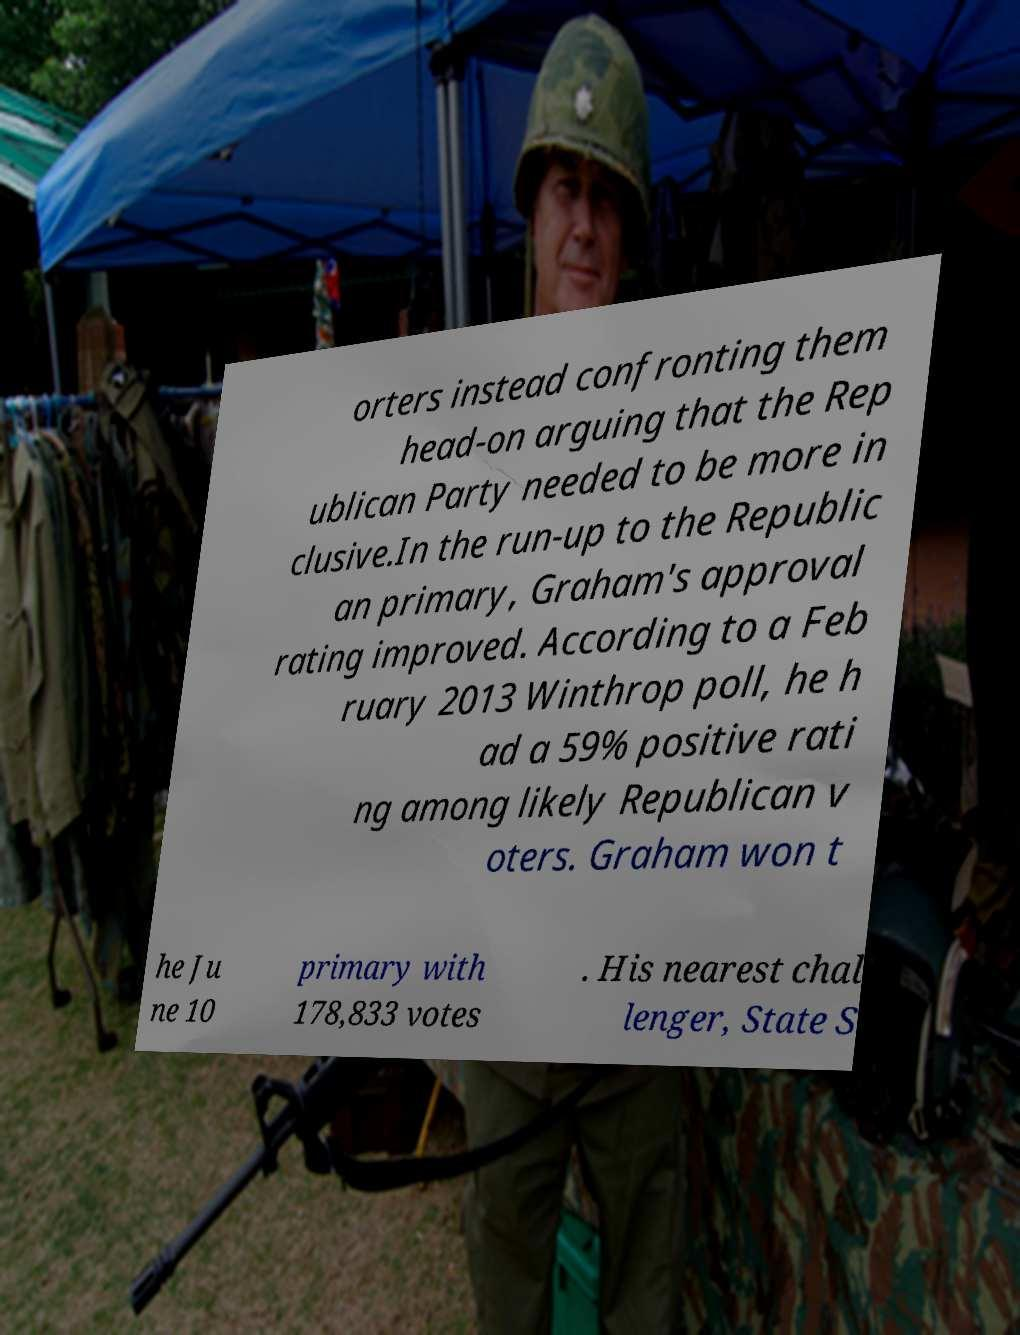Can you accurately transcribe the text from the provided image for me? orters instead confronting them head-on arguing that the Rep ublican Party needed to be more in clusive.In the run-up to the Republic an primary, Graham's approval rating improved. According to a Feb ruary 2013 Winthrop poll, he h ad a 59% positive rati ng among likely Republican v oters. Graham won t he Ju ne 10 primary with 178,833 votes . His nearest chal lenger, State S 